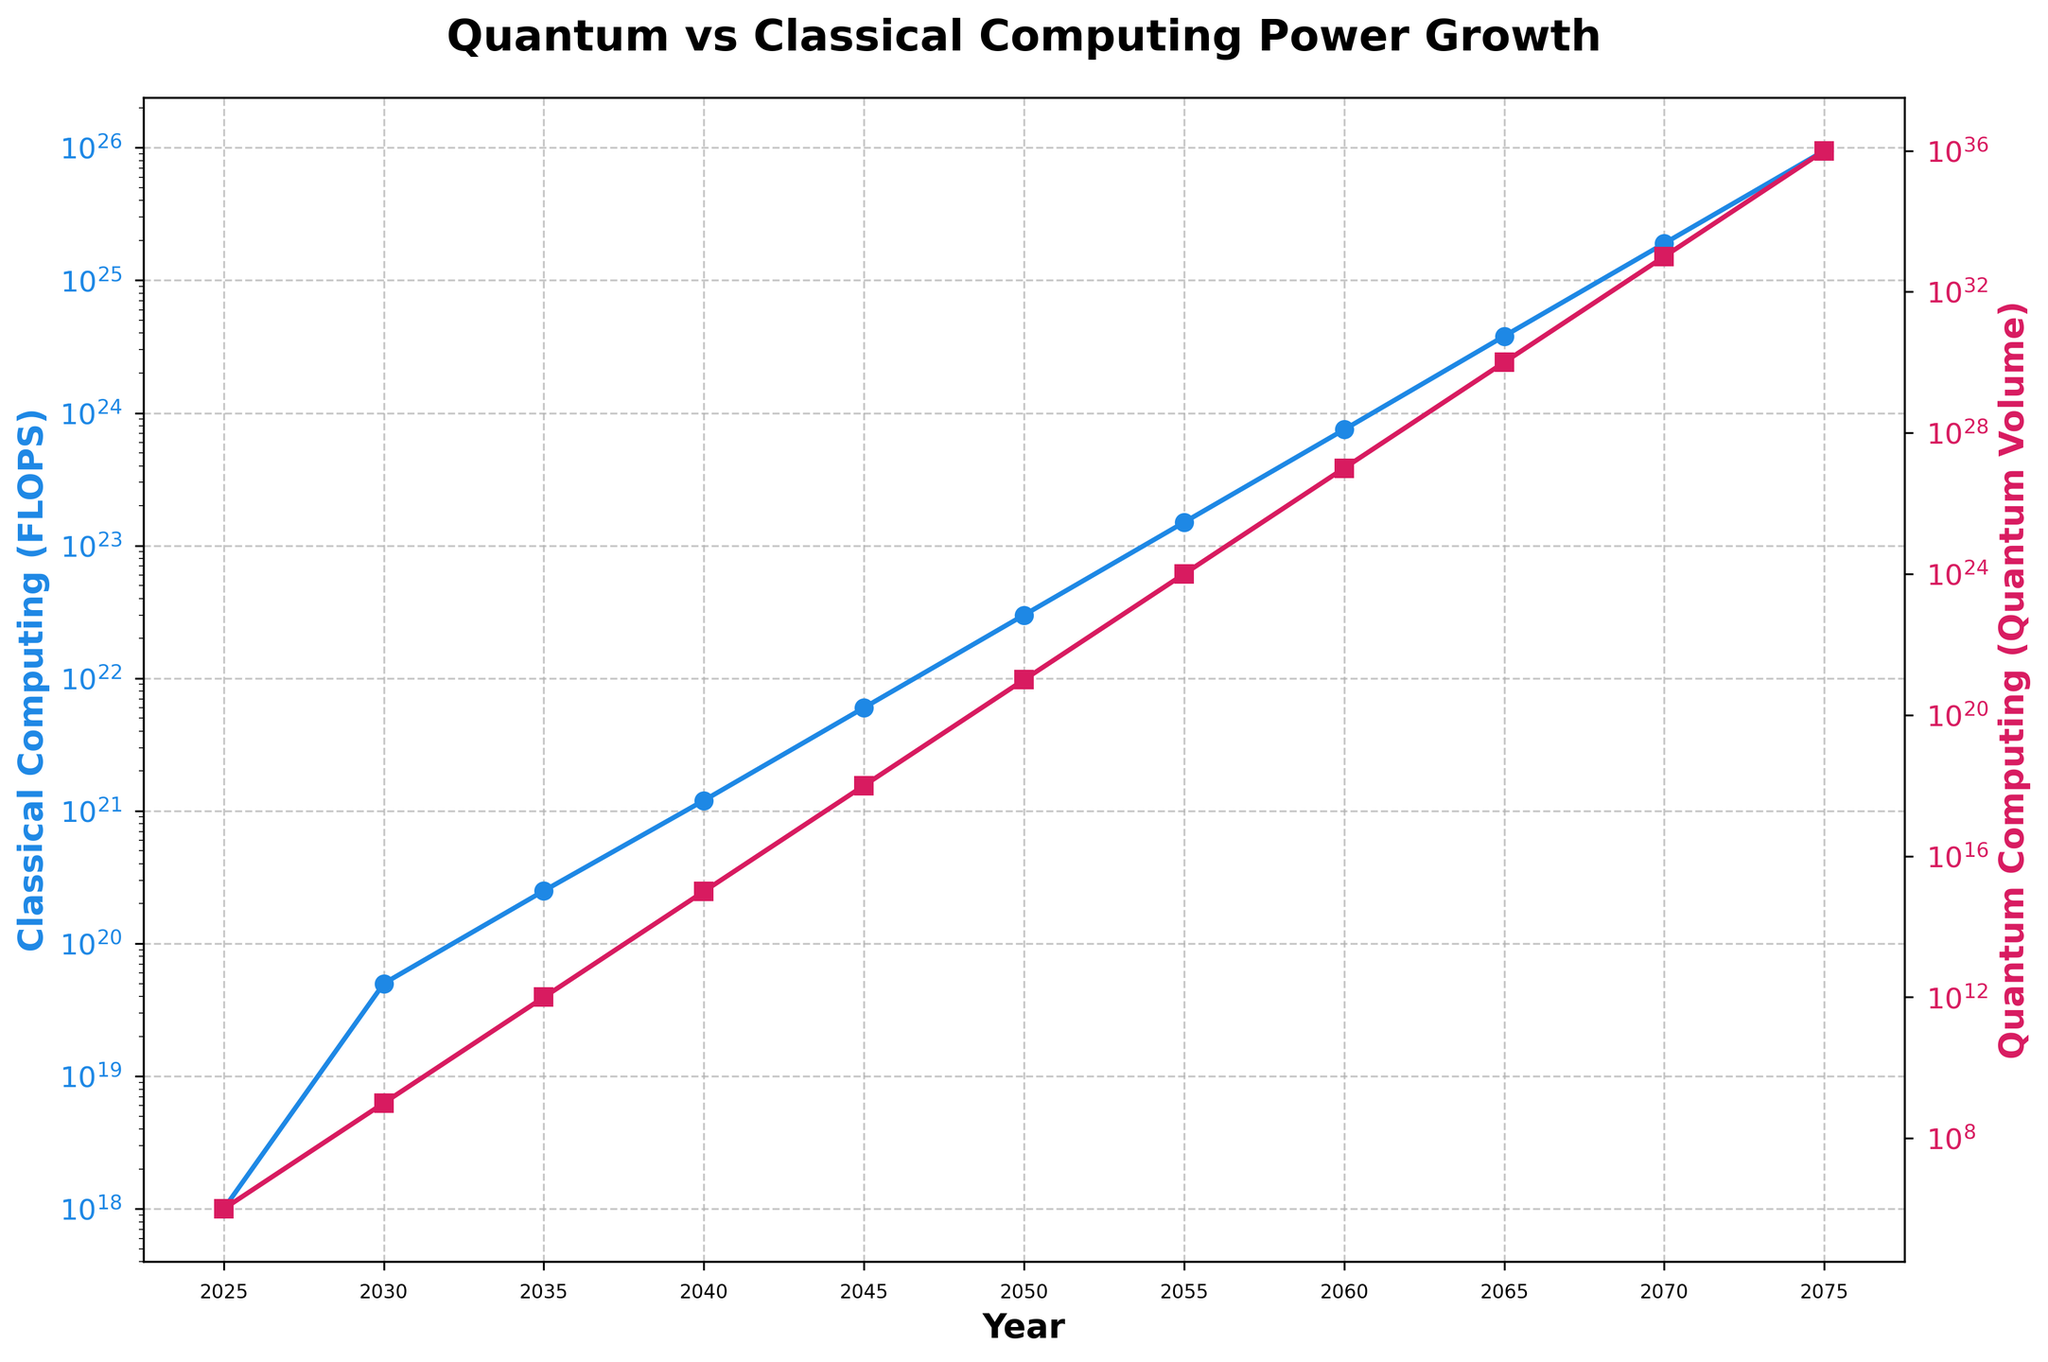What's the trend of Classical Computing processing power from 2025 to 2075? To identify the trend, observe the line representing Classical Computing (marked by blue). It starts at a lower value in 2025 and increases logarithmically up to 2075, depicting exponential growth.
Answer: Exponential growth How does the rate of growth compare between Quantum Computing and Classical Computing by 2060? Comparing the two trend lines by 2060, Classical Computing has grown to 7.5E+23 FLOPS, while Quantum Computing has grown to 1.0E+27 Quantum Volume. Quantum Computing grows much faster.
Answer: Quantum grows faster Which year sees Quantum Computing experience a jump of three orders of magnitude in its volume? Looking at the red line marking Quantum Volume, we see a jump from 1.0E+15 in 2040 to 1.0E+18 in 2045, which is an increase of three orders of magnitude.
Answer: 2045 In what year does Quantum Computing surpass the Classical Computing in the same order of magnitude? Analyzing both lines, Quantum Computing reaches a volume of 1.0E+24 in 2055 whereas Classical Computing continues below it at 1.5E+23. This is where Quantum surpasses Classical in the same order.
Answer: 2055 By how many orders of magnitude does the Quantum Volume increase between 2025 and 2075? The Quantum Volume grows from 1.0E+6 in 2025 to 1.0E+36 in 2075. Calculating the difference between the exponents 36 - 6, we see an increase of 30 orders of magnitude.
Answer: 30 orders What visual element distinguishes the plot lines of Quantum and Classical Computing? The plot lines are distinguished by color and marker type; Quantum Computing is represented by a red line with square markers, while Classical Computing is represented by a blue line with circular markers.
Answer: Color and marker type If the processing power growth continues, around which year does Classical Computing's performance reach approximately 1.0E+25 FLOPS? Observing the trendline for Classical Computing, it reaches a value close to 1.0E+25 FLOPS around the year 2070.
Answer: 2070 Between 2040 and 2050, by what factor does the Classical Computing processing power grow? The Classical Computing power in 2040 is 1.2E+21 FLOPS and grows to 3.0E+22 FLOPS by 2050. Dividing 3.0E+22 by 1.2E+21, we find the growth factor is 25.
Answer: 25 Which line experiences more significant curvature, indicating faster change rates, within the entire observed period? The red line for Quantum Computing shows significant curvature, visibly steeper and with larger logarithmic growth compared to the blue line for Classical Computing.
Answer: Quantum Computing What is a noticeable difference in the y-axis scale for Classical vs Quantum Computing? Classical Computing uses a FLOPS scale on the left y-axis, while Quantum Computing uses a Quantum Volume scale on the right y-axis. Both scales are logarithmic but indicate different magnitudes of measurement.
Answer: Different scales 